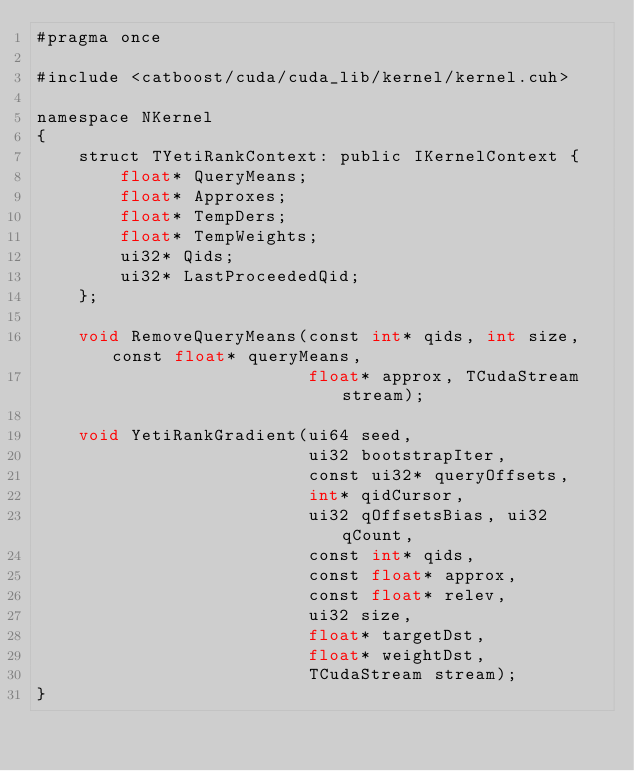<code> <loc_0><loc_0><loc_500><loc_500><_Cuda_>#pragma once

#include <catboost/cuda/cuda_lib/kernel/kernel.cuh>

namespace NKernel
{
    struct TYetiRankContext: public IKernelContext {
        float* QueryMeans;
        float* Approxes;
        float* TempDers;
        float* TempWeights;
        ui32* Qids;
        ui32* LastProceededQid;
    };

    void RemoveQueryMeans(const int* qids, int size, const float* queryMeans,
                          float* approx, TCudaStream stream);

    void YetiRankGradient(ui64 seed,
                          ui32 bootstrapIter,
                          const ui32* queryOffsets,
                          int* qidCursor,
                          ui32 qOffsetsBias, ui32 qCount,
                          const int* qids,
                          const float* approx,
                          const float* relev,
                          ui32 size,
                          float* targetDst,
                          float* weightDst,
                          TCudaStream stream);
}
</code> 